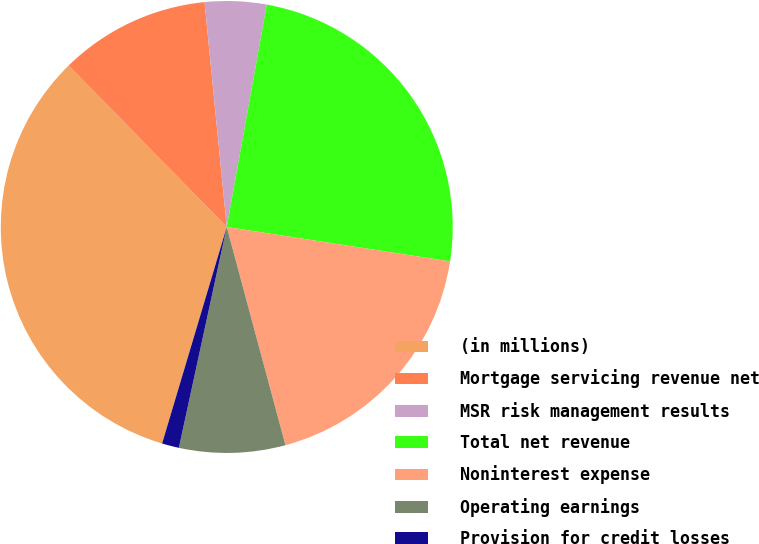<chart> <loc_0><loc_0><loc_500><loc_500><pie_chart><fcel>(in millions)<fcel>Mortgage servicing revenue net<fcel>MSR risk management results<fcel>Total net revenue<fcel>Noninterest expense<fcel>Operating earnings<fcel>Provision for credit losses<nl><fcel>33.04%<fcel>10.77%<fcel>4.4%<fcel>24.6%<fcel>18.38%<fcel>7.58%<fcel>1.22%<nl></chart> 